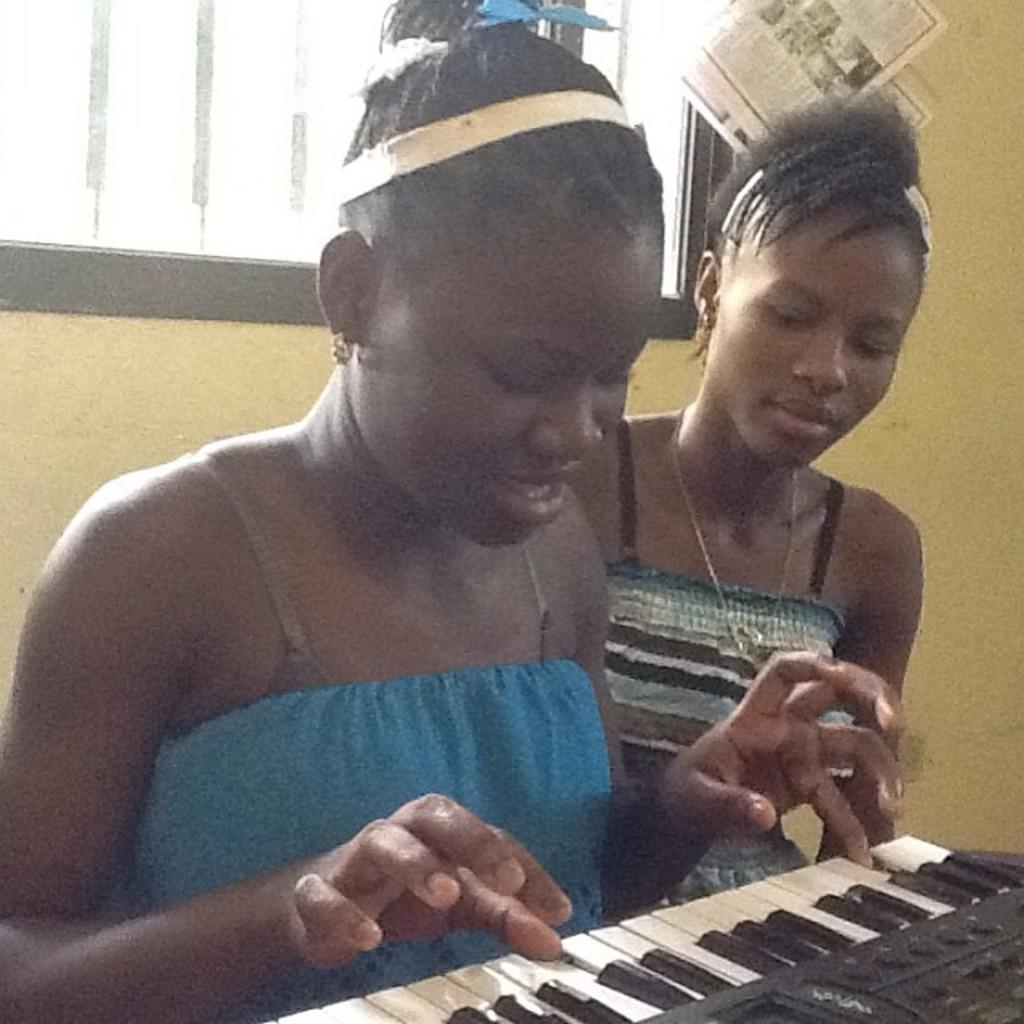In one or two sentences, can you explain what this image depicts? There are two girls in the image where the girl wearing a blue dress is playing piano and the girl sitting next to her is watching. In the background we can see a window and a poster attached to the wall. 